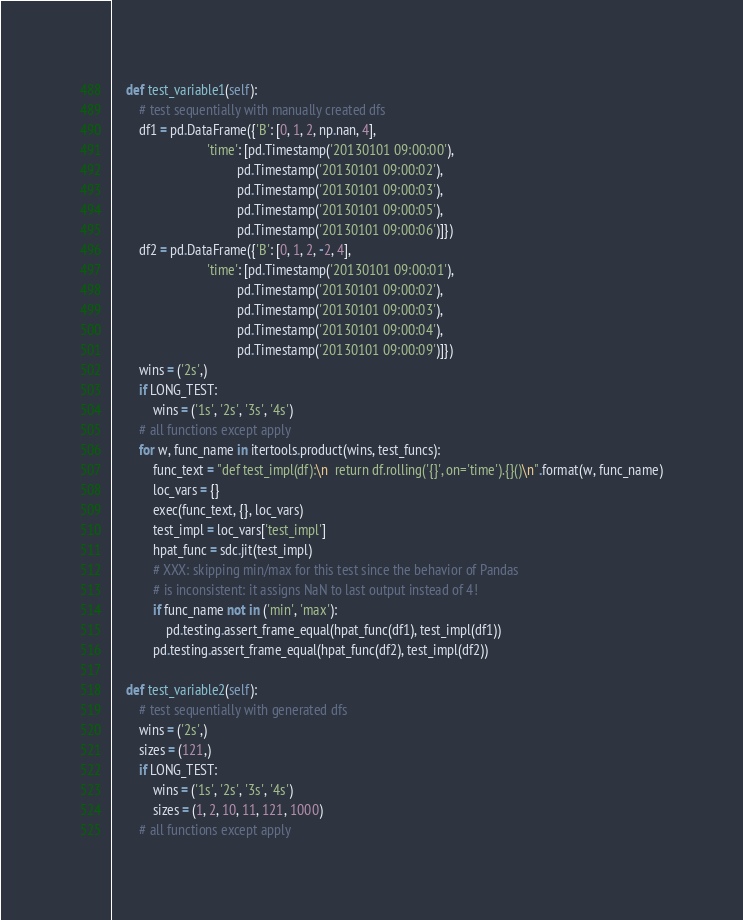Convert code to text. <code><loc_0><loc_0><loc_500><loc_500><_Python_>
    def test_variable1(self):
        # test sequentially with manually created dfs
        df1 = pd.DataFrame({'B': [0, 1, 2, np.nan, 4],
                            'time': [pd.Timestamp('20130101 09:00:00'),
                                     pd.Timestamp('20130101 09:00:02'),
                                     pd.Timestamp('20130101 09:00:03'),
                                     pd.Timestamp('20130101 09:00:05'),
                                     pd.Timestamp('20130101 09:00:06')]})
        df2 = pd.DataFrame({'B': [0, 1, 2, -2, 4],
                            'time': [pd.Timestamp('20130101 09:00:01'),
                                     pd.Timestamp('20130101 09:00:02'),
                                     pd.Timestamp('20130101 09:00:03'),
                                     pd.Timestamp('20130101 09:00:04'),
                                     pd.Timestamp('20130101 09:00:09')]})
        wins = ('2s',)
        if LONG_TEST:
            wins = ('1s', '2s', '3s', '4s')
        # all functions except apply
        for w, func_name in itertools.product(wins, test_funcs):
            func_text = "def test_impl(df):\n  return df.rolling('{}', on='time').{}()\n".format(w, func_name)
            loc_vars = {}
            exec(func_text, {}, loc_vars)
            test_impl = loc_vars['test_impl']
            hpat_func = sdc.jit(test_impl)
            # XXX: skipping min/max for this test since the behavior of Pandas
            # is inconsistent: it assigns NaN to last output instead of 4!
            if func_name not in ('min', 'max'):
                pd.testing.assert_frame_equal(hpat_func(df1), test_impl(df1))
            pd.testing.assert_frame_equal(hpat_func(df2), test_impl(df2))

    def test_variable2(self):
        # test sequentially with generated dfs
        wins = ('2s',)
        sizes = (121,)
        if LONG_TEST:
            wins = ('1s', '2s', '3s', '4s')
            sizes = (1, 2, 10, 11, 121, 1000)
        # all functions except apply</code> 